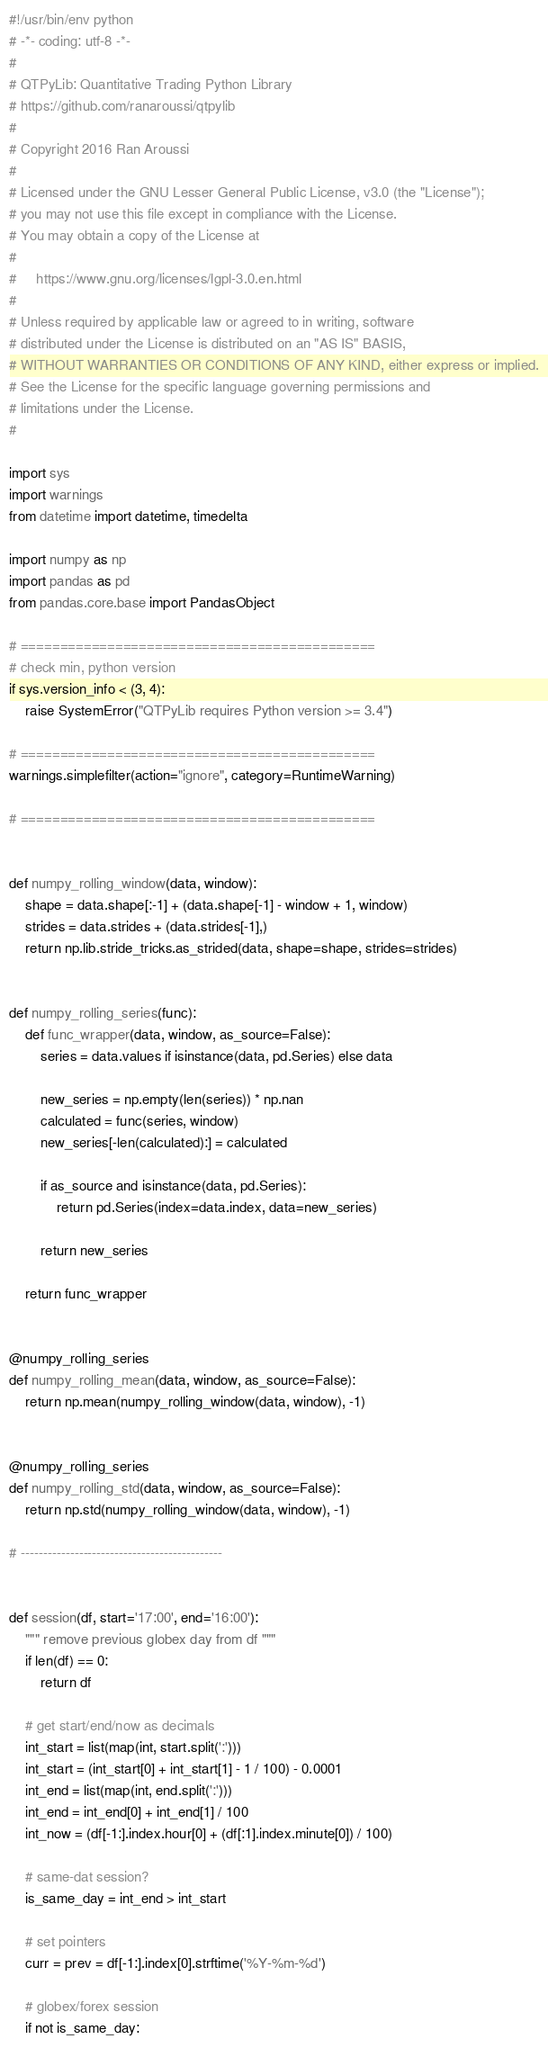<code> <loc_0><loc_0><loc_500><loc_500><_Python_>#!/usr/bin/env python
# -*- coding: utf-8 -*-
#
# QTPyLib: Quantitative Trading Python Library
# https://github.com/ranaroussi/qtpylib
#
# Copyright 2016 Ran Aroussi
#
# Licensed under the GNU Lesser General Public License, v3.0 (the "License");
# you may not use this file except in compliance with the License.
# You may obtain a copy of the License at
#
#     https://www.gnu.org/licenses/lgpl-3.0.en.html
#
# Unless required by applicable law or agreed to in writing, software
# distributed under the License is distributed on an "AS IS" BASIS,
# WITHOUT WARRANTIES OR CONDITIONS OF ANY KIND, either express or implied.
# See the License for the specific language governing permissions and
# limitations under the License.
#

import sys
import warnings
from datetime import datetime, timedelta

import numpy as np
import pandas as pd
from pandas.core.base import PandasObject

# =============================================
# check min, python version
if sys.version_info < (3, 4):
    raise SystemError("QTPyLib requires Python version >= 3.4")

# =============================================
warnings.simplefilter(action="ignore", category=RuntimeWarning)

# =============================================


def numpy_rolling_window(data, window):
    shape = data.shape[:-1] + (data.shape[-1] - window + 1, window)
    strides = data.strides + (data.strides[-1],)
    return np.lib.stride_tricks.as_strided(data, shape=shape, strides=strides)


def numpy_rolling_series(func):
    def func_wrapper(data, window, as_source=False):
        series = data.values if isinstance(data, pd.Series) else data

        new_series = np.empty(len(series)) * np.nan
        calculated = func(series, window)
        new_series[-len(calculated):] = calculated

        if as_source and isinstance(data, pd.Series):
            return pd.Series(index=data.index, data=new_series)

        return new_series

    return func_wrapper


@numpy_rolling_series
def numpy_rolling_mean(data, window, as_source=False):
    return np.mean(numpy_rolling_window(data, window), -1)


@numpy_rolling_series
def numpy_rolling_std(data, window, as_source=False):
    return np.std(numpy_rolling_window(data, window), -1)

# ---------------------------------------------


def session(df, start='17:00', end='16:00'):
    """ remove previous globex day from df """
    if len(df) == 0:
        return df

    # get start/end/now as decimals
    int_start = list(map(int, start.split(':')))
    int_start = (int_start[0] + int_start[1] - 1 / 100) - 0.0001
    int_end = list(map(int, end.split(':')))
    int_end = int_end[0] + int_end[1] / 100
    int_now = (df[-1:].index.hour[0] + (df[:1].index.minute[0]) / 100)

    # same-dat session?
    is_same_day = int_end > int_start

    # set pointers
    curr = prev = df[-1:].index[0].strftime('%Y-%m-%d')

    # globex/forex session
    if not is_same_day:</code> 